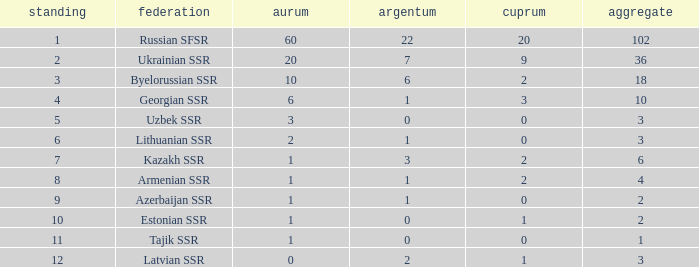What is the total number of bronzes associated with 1 silver, ranks under 6 and under 6 golds? None. 